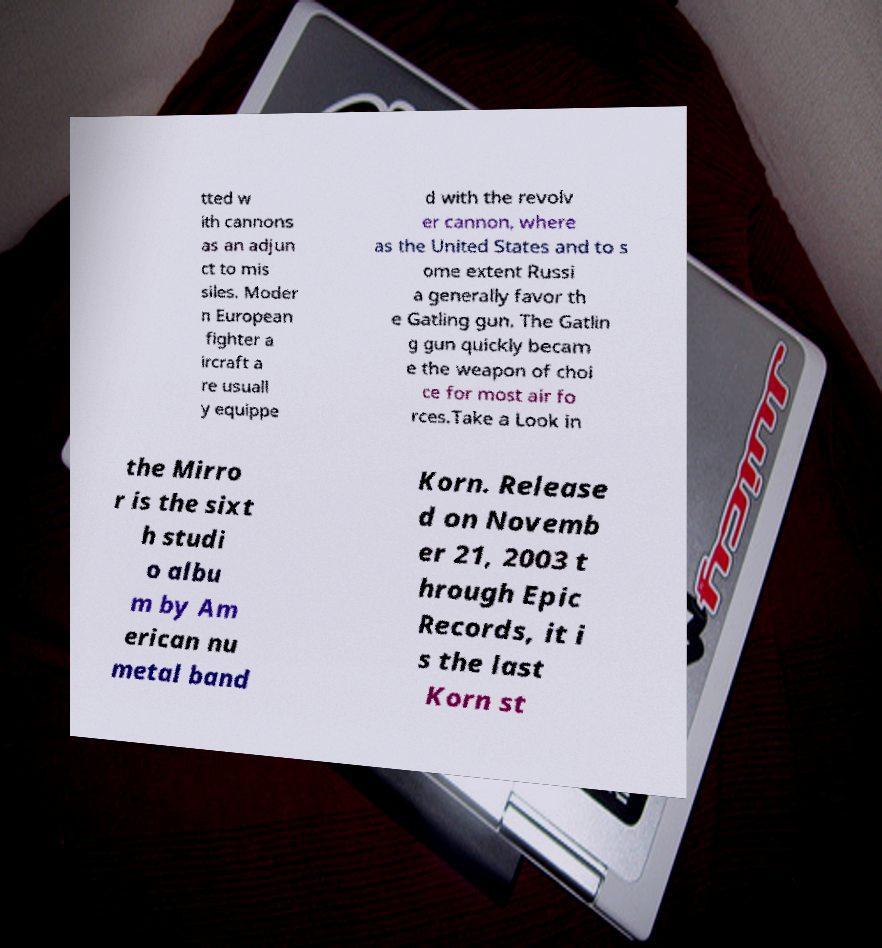Please identify and transcribe the text found in this image. tted w ith cannons as an adjun ct to mis siles. Moder n European fighter a ircraft a re usuall y equippe d with the revolv er cannon, where as the United States and to s ome extent Russi a generally favor th e Gatling gun. The Gatlin g gun quickly becam e the weapon of choi ce for most air fo rces.Take a Look in the Mirro r is the sixt h studi o albu m by Am erican nu metal band Korn. Release d on Novemb er 21, 2003 t hrough Epic Records, it i s the last Korn st 